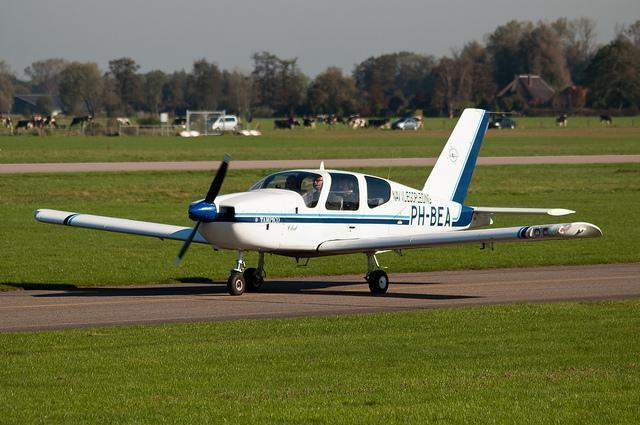What type of settlements are near the airport?
Make your selection and explain in format: 'Answer: answer
Rationale: rationale.'
Options: Sky scrapers, tennis clubs, farm, power plant. Answer: farm.
Rationale: There is a lot of land. What area is behind Plane runway?
Choose the right answer from the provided options to respond to the question.
Options: Political building, cow field, munitions plant, mall. Cow field. 